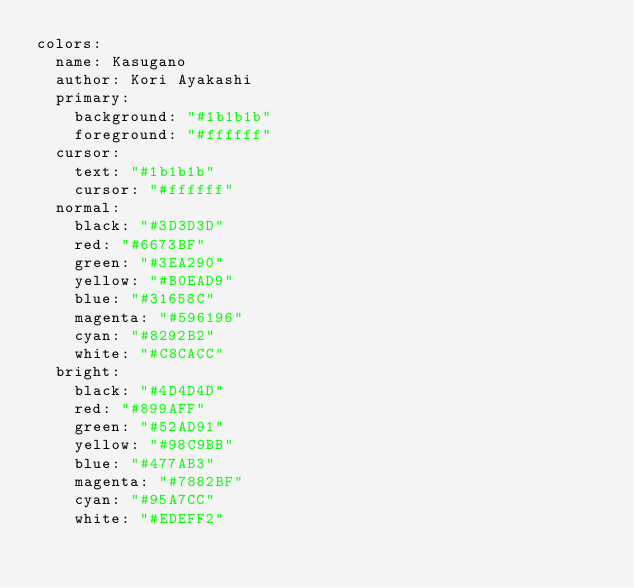Convert code to text. <code><loc_0><loc_0><loc_500><loc_500><_YAML_>colors:
  name: Kasugano
  author: Kori Ayakashi
  primary:
    background: "#1b1b1b"
    foreground: "#ffffff"
  cursor:
    text: "#1b1b1b"
    cursor: "#ffffff"
  normal:
    black: "#3D3D3D"
    red: "#6673BF"
    green: "#3EA290"
    yellow: "#B0EAD9"
    blue: "#31658C"
    magenta: "#596196"
    cyan: "#8292B2"
    white: "#C8CACC"
  bright:
    black: "#4D4D4D"
    red: "#899AFF"
    green: "#52AD91"
    yellow: "#98C9BB"
    blue: "#477AB3"
    magenta: "#7882BF"
    cyan: "#95A7CC"
    white: "#EDEFF2"
</code> 